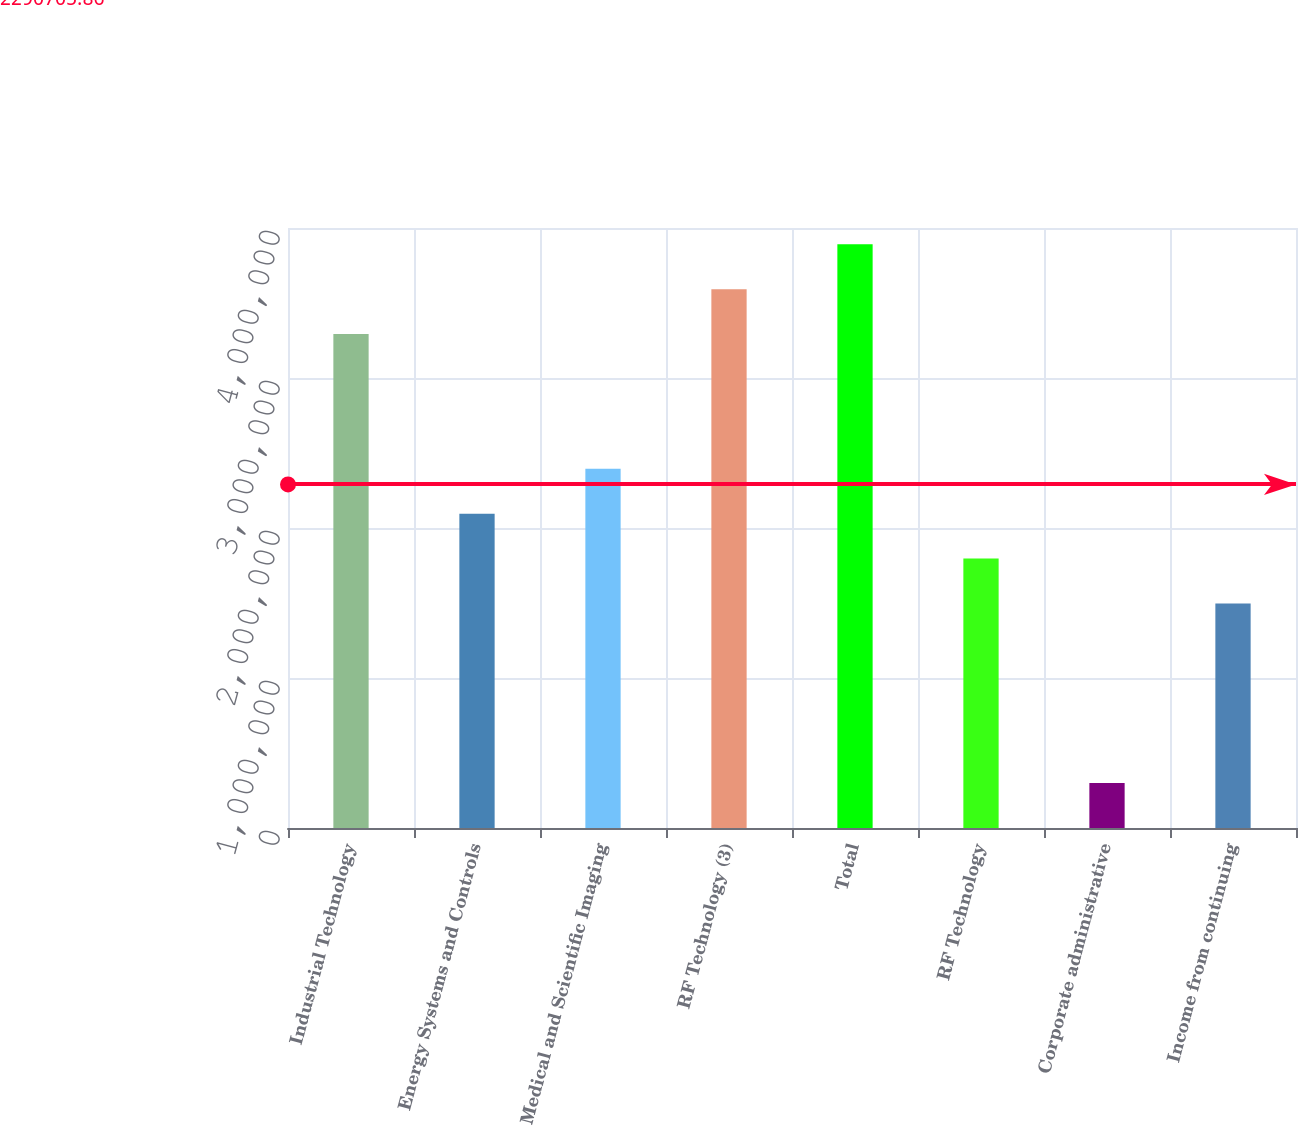<chart> <loc_0><loc_0><loc_500><loc_500><bar_chart><fcel>Industrial Technology<fcel>Energy Systems and Controls<fcel>Medical and Scientific Imaging<fcel>RF Technology (3)<fcel>Total<fcel>RF Technology<fcel>Corporate administrative<fcel>Income from continuing<nl><fcel>3.29284e+06<fcel>2.09544e+06<fcel>2.39479e+06<fcel>3.59219e+06<fcel>3.89154e+06<fcel>1.79609e+06<fcel>299351<fcel>1.49675e+06<nl></chart> 